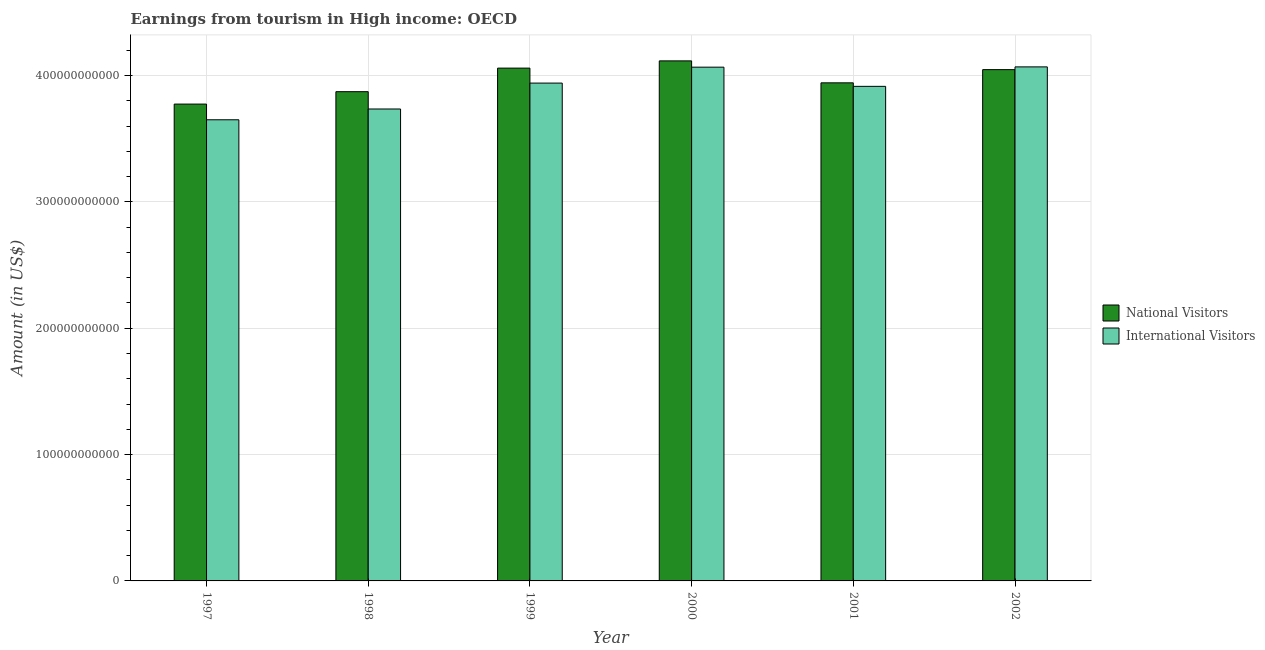Are the number of bars on each tick of the X-axis equal?
Offer a very short reply. Yes. How many bars are there on the 3rd tick from the left?
Provide a short and direct response. 2. How many bars are there on the 1st tick from the right?
Offer a very short reply. 2. In how many cases, is the number of bars for a given year not equal to the number of legend labels?
Your answer should be very brief. 0. What is the amount earned from international visitors in 2001?
Your response must be concise. 3.91e+11. Across all years, what is the maximum amount earned from international visitors?
Offer a very short reply. 4.07e+11. Across all years, what is the minimum amount earned from international visitors?
Offer a very short reply. 3.65e+11. What is the total amount earned from international visitors in the graph?
Make the answer very short. 2.34e+12. What is the difference between the amount earned from international visitors in 1997 and that in 2000?
Offer a terse response. -4.16e+1. What is the difference between the amount earned from national visitors in 2000 and the amount earned from international visitors in 2001?
Give a very brief answer. 1.74e+1. What is the average amount earned from national visitors per year?
Keep it short and to the point. 3.97e+11. In how many years, is the amount earned from international visitors greater than 380000000000 US$?
Offer a terse response. 4. What is the ratio of the amount earned from national visitors in 2001 to that in 2002?
Your answer should be compact. 0.97. Is the amount earned from international visitors in 1997 less than that in 1998?
Make the answer very short. Yes. What is the difference between the highest and the second highest amount earned from national visitors?
Offer a terse response. 5.73e+09. What is the difference between the highest and the lowest amount earned from national visitors?
Give a very brief answer. 3.42e+1. In how many years, is the amount earned from international visitors greater than the average amount earned from international visitors taken over all years?
Provide a short and direct response. 4. Is the sum of the amount earned from international visitors in 1998 and 2000 greater than the maximum amount earned from national visitors across all years?
Offer a very short reply. Yes. What does the 2nd bar from the left in 2002 represents?
Ensure brevity in your answer.  International Visitors. What does the 1st bar from the right in 2000 represents?
Give a very brief answer. International Visitors. Are all the bars in the graph horizontal?
Your answer should be compact. No. How many years are there in the graph?
Your answer should be very brief. 6. What is the difference between two consecutive major ticks on the Y-axis?
Your response must be concise. 1.00e+11. Are the values on the major ticks of Y-axis written in scientific E-notation?
Offer a terse response. No. Does the graph contain any zero values?
Give a very brief answer. No. Does the graph contain grids?
Your response must be concise. Yes. Where does the legend appear in the graph?
Your answer should be compact. Center right. How are the legend labels stacked?
Provide a short and direct response. Vertical. What is the title of the graph?
Provide a short and direct response. Earnings from tourism in High income: OECD. What is the label or title of the X-axis?
Ensure brevity in your answer.  Year. What is the label or title of the Y-axis?
Offer a terse response. Amount (in US$). What is the Amount (in US$) in National Visitors in 1997?
Provide a succinct answer. 3.77e+11. What is the Amount (in US$) in International Visitors in 1997?
Provide a succinct answer. 3.65e+11. What is the Amount (in US$) in National Visitors in 1998?
Ensure brevity in your answer.  3.87e+11. What is the Amount (in US$) of International Visitors in 1998?
Provide a succinct answer. 3.73e+11. What is the Amount (in US$) in National Visitors in 1999?
Provide a short and direct response. 4.06e+11. What is the Amount (in US$) in International Visitors in 1999?
Give a very brief answer. 3.94e+11. What is the Amount (in US$) in National Visitors in 2000?
Offer a terse response. 4.12e+11. What is the Amount (in US$) of International Visitors in 2000?
Ensure brevity in your answer.  4.07e+11. What is the Amount (in US$) in National Visitors in 2001?
Offer a very short reply. 3.94e+11. What is the Amount (in US$) in International Visitors in 2001?
Your response must be concise. 3.91e+11. What is the Amount (in US$) in National Visitors in 2002?
Keep it short and to the point. 4.05e+11. What is the Amount (in US$) of International Visitors in 2002?
Offer a terse response. 4.07e+11. Across all years, what is the maximum Amount (in US$) of National Visitors?
Offer a terse response. 4.12e+11. Across all years, what is the maximum Amount (in US$) of International Visitors?
Your response must be concise. 4.07e+11. Across all years, what is the minimum Amount (in US$) of National Visitors?
Make the answer very short. 3.77e+11. Across all years, what is the minimum Amount (in US$) of International Visitors?
Your answer should be very brief. 3.65e+11. What is the total Amount (in US$) of National Visitors in the graph?
Provide a short and direct response. 2.38e+12. What is the total Amount (in US$) in International Visitors in the graph?
Provide a short and direct response. 2.34e+12. What is the difference between the Amount (in US$) of National Visitors in 1997 and that in 1998?
Keep it short and to the point. -9.81e+09. What is the difference between the Amount (in US$) of International Visitors in 1997 and that in 1998?
Your answer should be compact. -8.53e+09. What is the difference between the Amount (in US$) in National Visitors in 1997 and that in 1999?
Give a very brief answer. -2.85e+1. What is the difference between the Amount (in US$) of International Visitors in 1997 and that in 1999?
Provide a succinct answer. -2.90e+1. What is the difference between the Amount (in US$) of National Visitors in 1997 and that in 2000?
Your response must be concise. -3.42e+1. What is the difference between the Amount (in US$) in International Visitors in 1997 and that in 2000?
Provide a short and direct response. -4.16e+1. What is the difference between the Amount (in US$) in National Visitors in 1997 and that in 2001?
Give a very brief answer. -1.68e+1. What is the difference between the Amount (in US$) of International Visitors in 1997 and that in 2001?
Ensure brevity in your answer.  -2.64e+1. What is the difference between the Amount (in US$) in National Visitors in 1997 and that in 2002?
Provide a succinct answer. -2.73e+1. What is the difference between the Amount (in US$) in International Visitors in 1997 and that in 2002?
Offer a terse response. -4.19e+1. What is the difference between the Amount (in US$) in National Visitors in 1998 and that in 1999?
Your answer should be compact. -1.87e+1. What is the difference between the Amount (in US$) in International Visitors in 1998 and that in 1999?
Your answer should be compact. -2.05e+1. What is the difference between the Amount (in US$) of National Visitors in 1998 and that in 2000?
Ensure brevity in your answer.  -2.44e+1. What is the difference between the Amount (in US$) in International Visitors in 1998 and that in 2000?
Your answer should be compact. -3.31e+1. What is the difference between the Amount (in US$) in National Visitors in 1998 and that in 2001?
Keep it short and to the point. -7.01e+09. What is the difference between the Amount (in US$) of International Visitors in 1998 and that in 2001?
Keep it short and to the point. -1.79e+1. What is the difference between the Amount (in US$) of National Visitors in 1998 and that in 2002?
Provide a short and direct response. -1.75e+1. What is the difference between the Amount (in US$) of International Visitors in 1998 and that in 2002?
Provide a succinct answer. -3.33e+1. What is the difference between the Amount (in US$) in National Visitors in 1999 and that in 2000?
Provide a short and direct response. -5.73e+09. What is the difference between the Amount (in US$) in International Visitors in 1999 and that in 2000?
Give a very brief answer. -1.26e+1. What is the difference between the Amount (in US$) in National Visitors in 1999 and that in 2001?
Your response must be concise. 1.16e+1. What is the difference between the Amount (in US$) in International Visitors in 1999 and that in 2001?
Provide a succinct answer. 2.58e+09. What is the difference between the Amount (in US$) in National Visitors in 1999 and that in 2002?
Ensure brevity in your answer.  1.20e+09. What is the difference between the Amount (in US$) in International Visitors in 1999 and that in 2002?
Your response must be concise. -1.28e+1. What is the difference between the Amount (in US$) in National Visitors in 2000 and that in 2001?
Offer a very short reply. 1.74e+1. What is the difference between the Amount (in US$) of International Visitors in 2000 and that in 2001?
Offer a very short reply. 1.52e+1. What is the difference between the Amount (in US$) of National Visitors in 2000 and that in 2002?
Ensure brevity in your answer.  6.93e+09. What is the difference between the Amount (in US$) of International Visitors in 2000 and that in 2002?
Your answer should be very brief. -2.31e+08. What is the difference between the Amount (in US$) in National Visitors in 2001 and that in 2002?
Your answer should be very brief. -1.04e+1. What is the difference between the Amount (in US$) of International Visitors in 2001 and that in 2002?
Provide a short and direct response. -1.54e+1. What is the difference between the Amount (in US$) in National Visitors in 1997 and the Amount (in US$) in International Visitors in 1998?
Your response must be concise. 3.88e+09. What is the difference between the Amount (in US$) in National Visitors in 1997 and the Amount (in US$) in International Visitors in 1999?
Offer a terse response. -1.66e+1. What is the difference between the Amount (in US$) of National Visitors in 1997 and the Amount (in US$) of International Visitors in 2000?
Keep it short and to the point. -2.92e+1. What is the difference between the Amount (in US$) of National Visitors in 1997 and the Amount (in US$) of International Visitors in 2001?
Provide a succinct answer. -1.40e+1. What is the difference between the Amount (in US$) in National Visitors in 1997 and the Amount (in US$) in International Visitors in 2002?
Your answer should be compact. -2.94e+1. What is the difference between the Amount (in US$) in National Visitors in 1998 and the Amount (in US$) in International Visitors in 1999?
Provide a succinct answer. -6.81e+09. What is the difference between the Amount (in US$) of National Visitors in 1998 and the Amount (in US$) of International Visitors in 2000?
Your response must be concise. -1.94e+1. What is the difference between the Amount (in US$) of National Visitors in 1998 and the Amount (in US$) of International Visitors in 2001?
Keep it short and to the point. -4.22e+09. What is the difference between the Amount (in US$) of National Visitors in 1998 and the Amount (in US$) of International Visitors in 2002?
Your answer should be very brief. -1.96e+1. What is the difference between the Amount (in US$) in National Visitors in 1999 and the Amount (in US$) in International Visitors in 2000?
Offer a terse response. -7.46e+08. What is the difference between the Amount (in US$) of National Visitors in 1999 and the Amount (in US$) of International Visitors in 2001?
Give a very brief answer. 1.44e+1. What is the difference between the Amount (in US$) in National Visitors in 1999 and the Amount (in US$) in International Visitors in 2002?
Your answer should be very brief. -9.77e+08. What is the difference between the Amount (in US$) in National Visitors in 2000 and the Amount (in US$) in International Visitors in 2001?
Provide a short and direct response. 2.02e+1. What is the difference between the Amount (in US$) of National Visitors in 2000 and the Amount (in US$) of International Visitors in 2002?
Your answer should be compact. 4.75e+09. What is the difference between the Amount (in US$) of National Visitors in 2001 and the Amount (in US$) of International Visitors in 2002?
Provide a short and direct response. -1.26e+1. What is the average Amount (in US$) of National Visitors per year?
Your answer should be compact. 3.97e+11. What is the average Amount (in US$) in International Visitors per year?
Provide a succinct answer. 3.90e+11. In the year 1997, what is the difference between the Amount (in US$) in National Visitors and Amount (in US$) in International Visitors?
Give a very brief answer. 1.24e+1. In the year 1998, what is the difference between the Amount (in US$) in National Visitors and Amount (in US$) in International Visitors?
Offer a terse response. 1.37e+1. In the year 1999, what is the difference between the Amount (in US$) of National Visitors and Amount (in US$) of International Visitors?
Give a very brief answer. 1.18e+1. In the year 2000, what is the difference between the Amount (in US$) of National Visitors and Amount (in US$) of International Visitors?
Offer a very short reply. 4.98e+09. In the year 2001, what is the difference between the Amount (in US$) in National Visitors and Amount (in US$) in International Visitors?
Provide a short and direct response. 2.78e+09. In the year 2002, what is the difference between the Amount (in US$) of National Visitors and Amount (in US$) of International Visitors?
Make the answer very short. -2.18e+09. What is the ratio of the Amount (in US$) in National Visitors in 1997 to that in 1998?
Keep it short and to the point. 0.97. What is the ratio of the Amount (in US$) of International Visitors in 1997 to that in 1998?
Provide a succinct answer. 0.98. What is the ratio of the Amount (in US$) of National Visitors in 1997 to that in 1999?
Provide a short and direct response. 0.93. What is the ratio of the Amount (in US$) in International Visitors in 1997 to that in 1999?
Your response must be concise. 0.93. What is the ratio of the Amount (in US$) of National Visitors in 1997 to that in 2000?
Your answer should be compact. 0.92. What is the ratio of the Amount (in US$) in International Visitors in 1997 to that in 2000?
Offer a terse response. 0.9. What is the ratio of the Amount (in US$) of National Visitors in 1997 to that in 2001?
Keep it short and to the point. 0.96. What is the ratio of the Amount (in US$) in International Visitors in 1997 to that in 2001?
Provide a succinct answer. 0.93. What is the ratio of the Amount (in US$) in National Visitors in 1997 to that in 2002?
Make the answer very short. 0.93. What is the ratio of the Amount (in US$) in International Visitors in 1997 to that in 2002?
Give a very brief answer. 0.9. What is the ratio of the Amount (in US$) in National Visitors in 1998 to that in 1999?
Provide a short and direct response. 0.95. What is the ratio of the Amount (in US$) in International Visitors in 1998 to that in 1999?
Provide a succinct answer. 0.95. What is the ratio of the Amount (in US$) of National Visitors in 1998 to that in 2000?
Keep it short and to the point. 0.94. What is the ratio of the Amount (in US$) in International Visitors in 1998 to that in 2000?
Ensure brevity in your answer.  0.92. What is the ratio of the Amount (in US$) in National Visitors in 1998 to that in 2001?
Offer a very short reply. 0.98. What is the ratio of the Amount (in US$) of International Visitors in 1998 to that in 2001?
Keep it short and to the point. 0.95. What is the ratio of the Amount (in US$) in National Visitors in 1998 to that in 2002?
Your response must be concise. 0.96. What is the ratio of the Amount (in US$) in International Visitors in 1998 to that in 2002?
Offer a very short reply. 0.92. What is the ratio of the Amount (in US$) in National Visitors in 1999 to that in 2000?
Offer a terse response. 0.99. What is the ratio of the Amount (in US$) of International Visitors in 1999 to that in 2000?
Give a very brief answer. 0.97. What is the ratio of the Amount (in US$) in National Visitors in 1999 to that in 2001?
Give a very brief answer. 1.03. What is the ratio of the Amount (in US$) in International Visitors in 1999 to that in 2001?
Ensure brevity in your answer.  1.01. What is the ratio of the Amount (in US$) of International Visitors in 1999 to that in 2002?
Offer a very short reply. 0.97. What is the ratio of the Amount (in US$) in National Visitors in 2000 to that in 2001?
Your answer should be compact. 1.04. What is the ratio of the Amount (in US$) in International Visitors in 2000 to that in 2001?
Provide a short and direct response. 1.04. What is the ratio of the Amount (in US$) of National Visitors in 2000 to that in 2002?
Provide a succinct answer. 1.02. What is the ratio of the Amount (in US$) of National Visitors in 2001 to that in 2002?
Keep it short and to the point. 0.97. What is the ratio of the Amount (in US$) in International Visitors in 2001 to that in 2002?
Offer a very short reply. 0.96. What is the difference between the highest and the second highest Amount (in US$) of National Visitors?
Make the answer very short. 5.73e+09. What is the difference between the highest and the second highest Amount (in US$) in International Visitors?
Your answer should be very brief. 2.31e+08. What is the difference between the highest and the lowest Amount (in US$) of National Visitors?
Keep it short and to the point. 3.42e+1. What is the difference between the highest and the lowest Amount (in US$) in International Visitors?
Your answer should be very brief. 4.19e+1. 